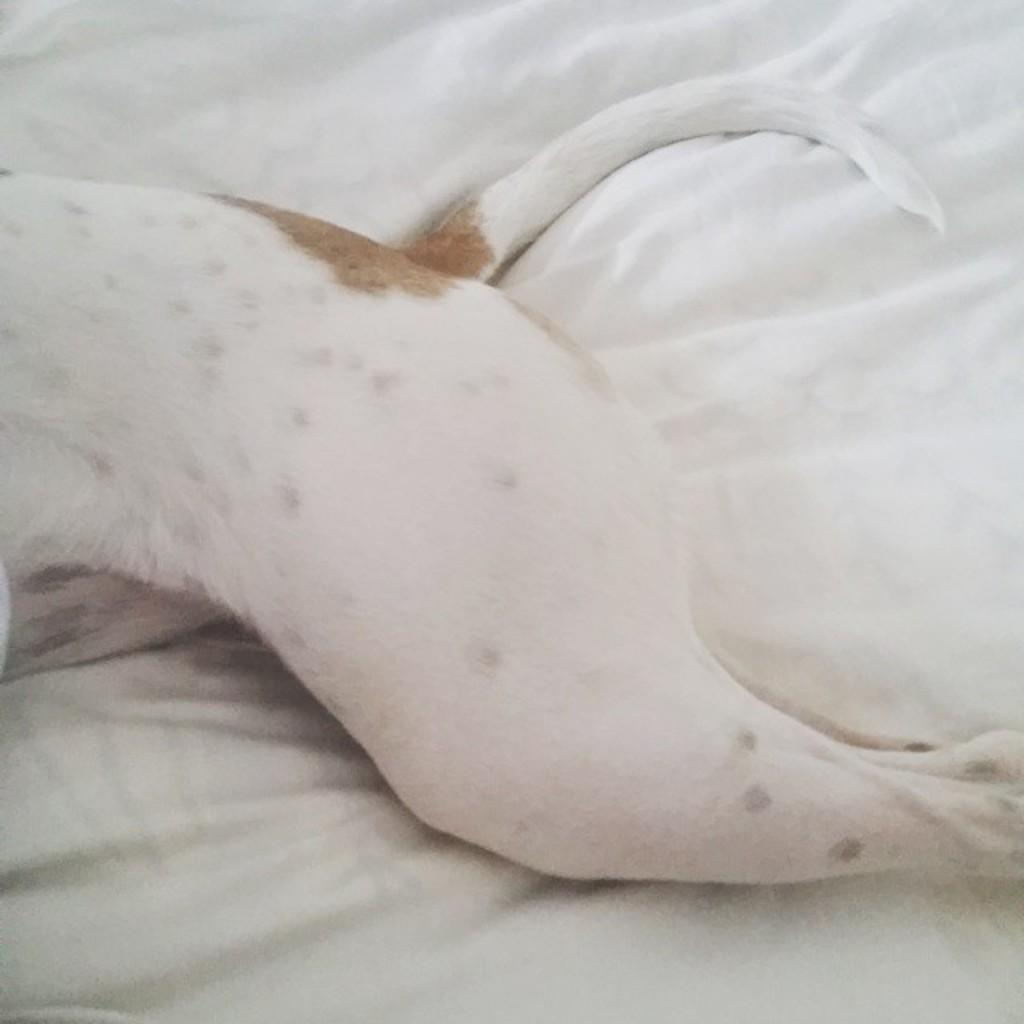What type of creature is in the image? There is an animal in the image. Where is the animal located? The animal is on a white cloth. What type of plough is being used by the animal in the image? There is no plough present in the image; it only features an animal on a white cloth. 